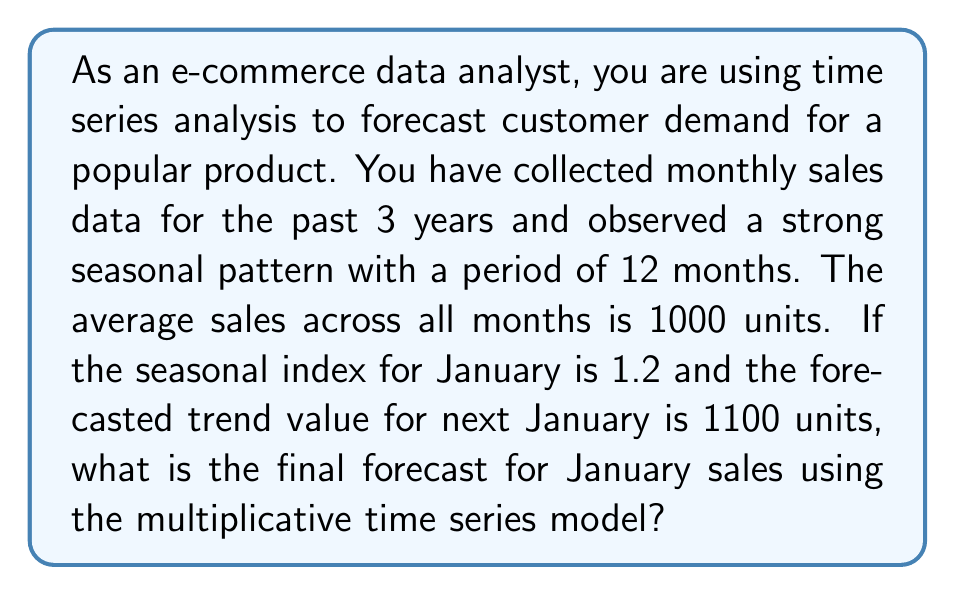Can you answer this question? To solve this problem, we'll use the multiplicative time series model, which is given by:

$$Y_t = T_t \times S_t \times E_t$$

Where:
$Y_t$ = Forecast value
$T_t$ = Trend component
$S_t$ = Seasonal component
$E_t$ = Error component (assumed to be 1 for forecasting)

Step 1: Identify the components
- Trend ($T_t$) = 1100 units (given in the question)
- Seasonal index for January ($S_t$) = 1.2 (given in the question)
- Error component ($E_t$) = 1 (assumed for forecasting)

Step 2: Apply the multiplicative model
$$Y_t = T_t \times S_t \times E_t$$
$$Y_t = 1100 \times 1.2 \times 1$$

Step 3: Calculate the final forecast
$$Y_t = 1100 \times 1.2 = 1320$$

Therefore, the final forecast for January sales is 1320 units.
Answer: 1320 units 